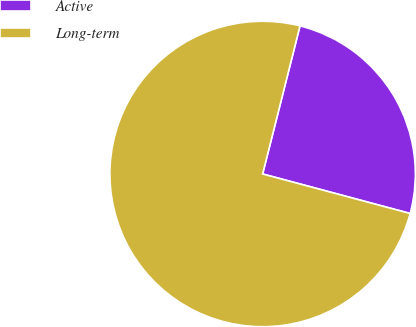Convert chart to OTSL. <chart><loc_0><loc_0><loc_500><loc_500><pie_chart><fcel>Active<fcel>Long-term<nl><fcel>25.23%<fcel>74.77%<nl></chart> 